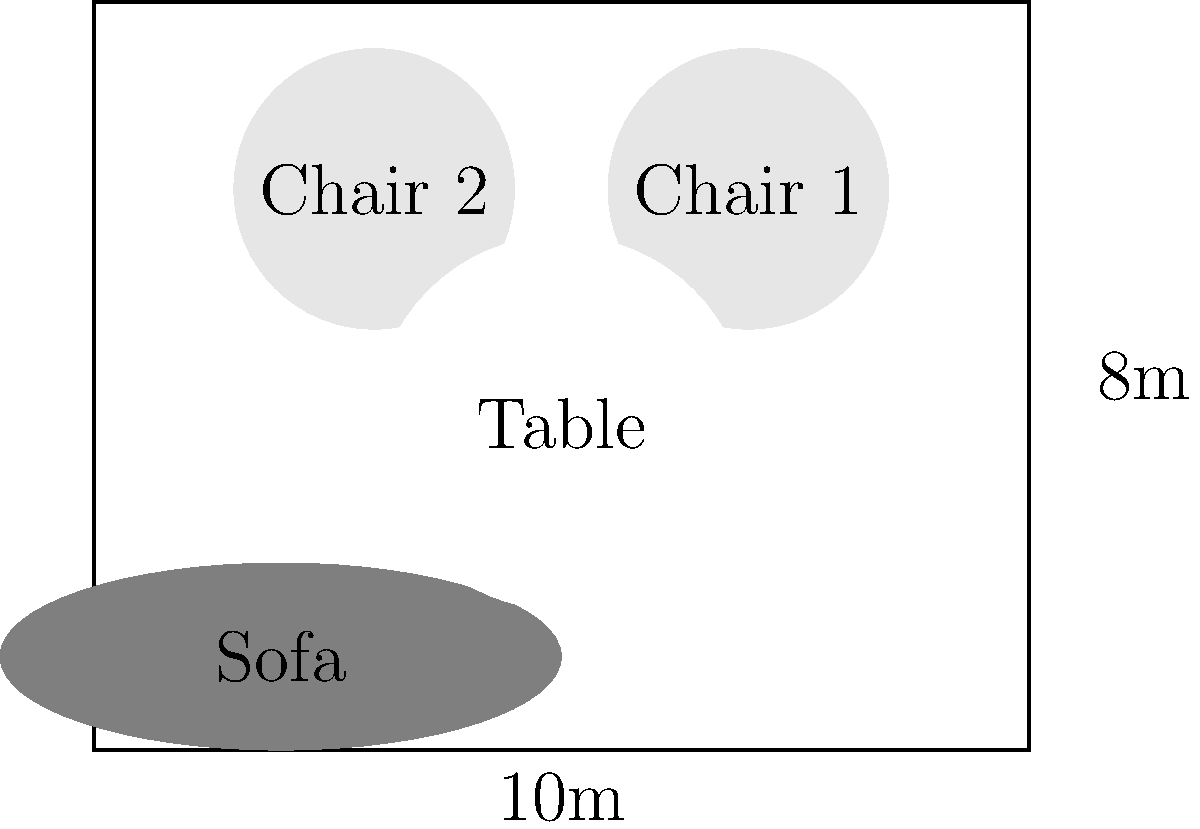As an antique furniture restorer, you're tasked with arranging a living room for a client. The room measures 10m x 8m and contains a large antique sofa, two restored Victorian chairs, and a refinished coffee table. Given the current arrangement shown in the diagram, how can you optimize the layout to create better flow and more open space? Propose a new arrangement and explain your reasoning. To optimize the layout, we should consider the following steps:

1. Analyze the current layout:
   - The sofa is placed against the bottom wall
   - The chairs are positioned at the top of the room
   - The table is in the center

2. Identify issues:
   - The furniture is spread out, creating a disconnected feel
   - There's no clear focal point or conversation area
   - The arrangement doesn't maximize open space

3. Propose a new arrangement:
   - Move the sofa to the left wall, centered at (1m, 4m)
   - Place Chair 1 at (4m, 6m), angled slightly towards the sofa
   - Position Chair 2 at (4m, 2m), also angled towards the sofa
   - Center the coffee table at (3m, 4m)

4. Explain the benefits:
   - This creates a cozy conversation area
   - It opens up the right side of the room for better flow
   - The arrangement utilizes the corner, maximizing open space
   - It allows for easy viewing of a potential TV or fireplace on the right wall

5. Consider the restoration perspective:
   - This arrangement showcases the antique sofa as a focal point
   - The Victorian chairs are positioned to highlight their restored beauty
   - The refinished coffee table ties the seating area together

6. Maintenance considerations:
   - The new layout allows easier access for applying waxes and polishes
   - It provides space for periodic inspections and touch-ups of the furniture
Answer: Move sofa to left wall; chairs angled on either side; table centered between them. 